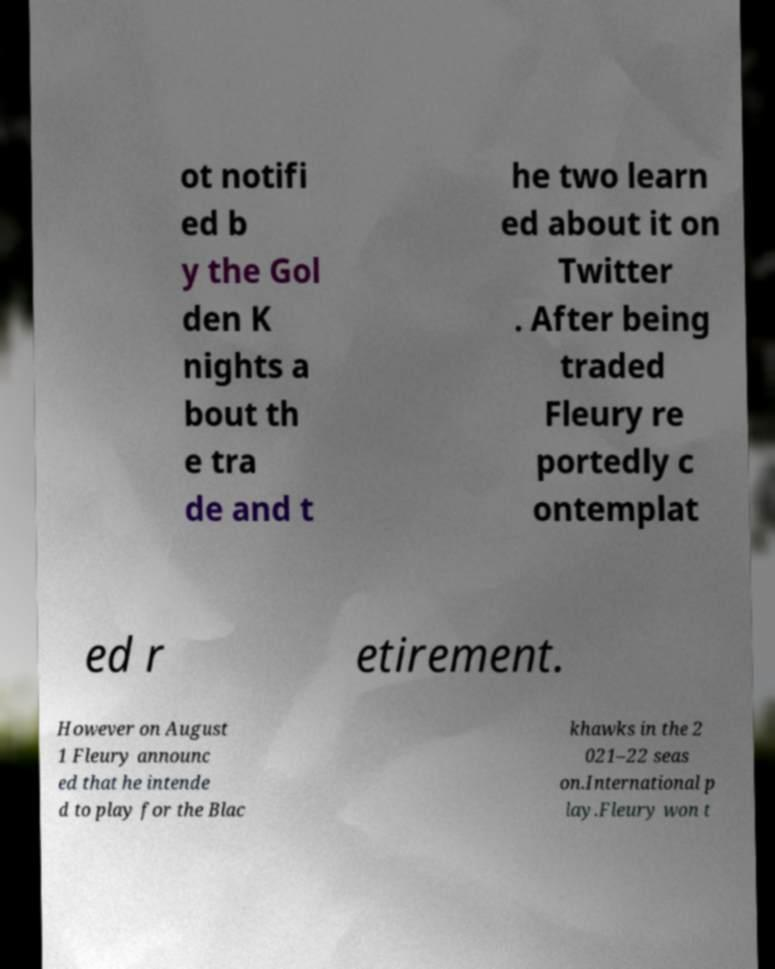Can you accurately transcribe the text from the provided image for me? ot notifi ed b y the Gol den K nights a bout th e tra de and t he two learn ed about it on Twitter . After being traded Fleury re portedly c ontemplat ed r etirement. However on August 1 Fleury announc ed that he intende d to play for the Blac khawks in the 2 021–22 seas on.International p lay.Fleury won t 